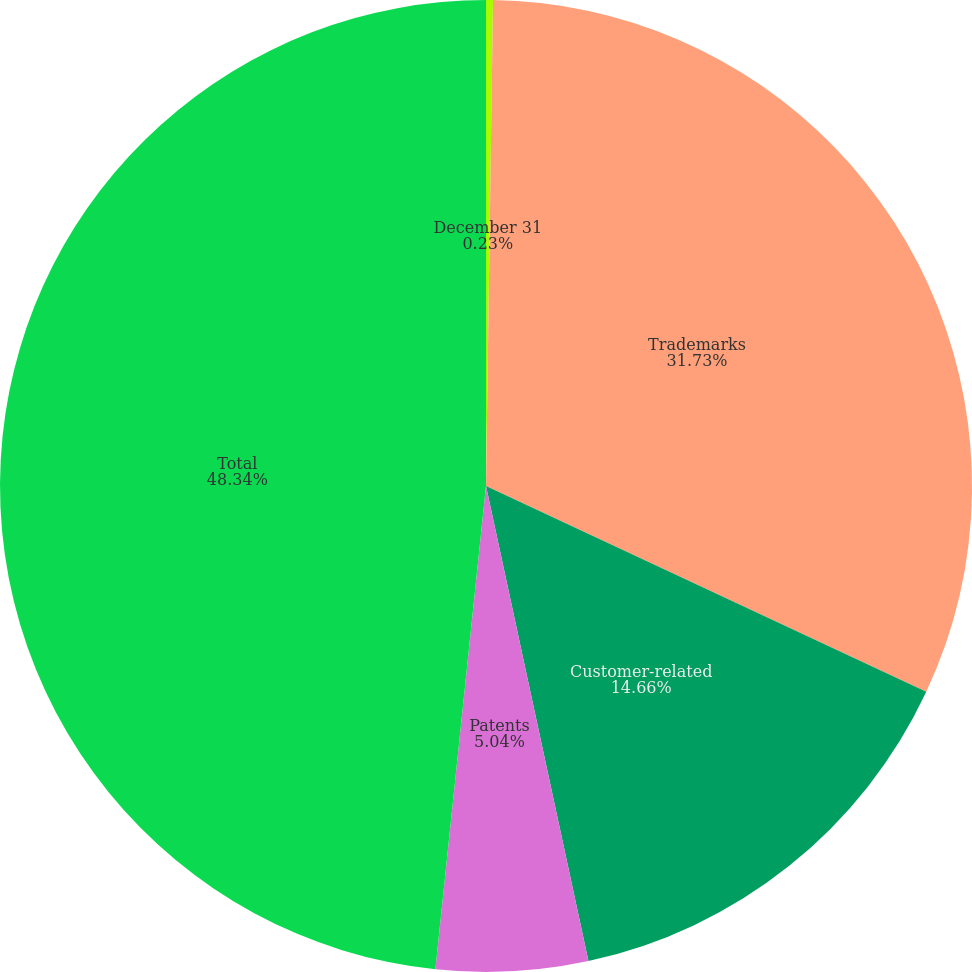<chart> <loc_0><loc_0><loc_500><loc_500><pie_chart><fcel>December 31<fcel>Trademarks<fcel>Customer-related<fcel>Patents<fcel>Total<nl><fcel>0.23%<fcel>31.73%<fcel>14.66%<fcel>5.04%<fcel>48.34%<nl></chart> 